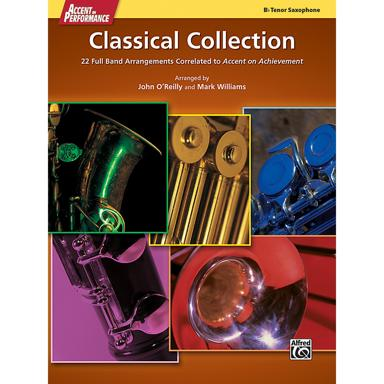Could you elaborate on what 'Accent on Achievement' is? 'Accent on Achievement' is a widely recognized band method series that provides an innovative, comprehensive curriculum for music education. It's designed to motivate and inspire students while emphasizing the development of skills and musical understanding. 